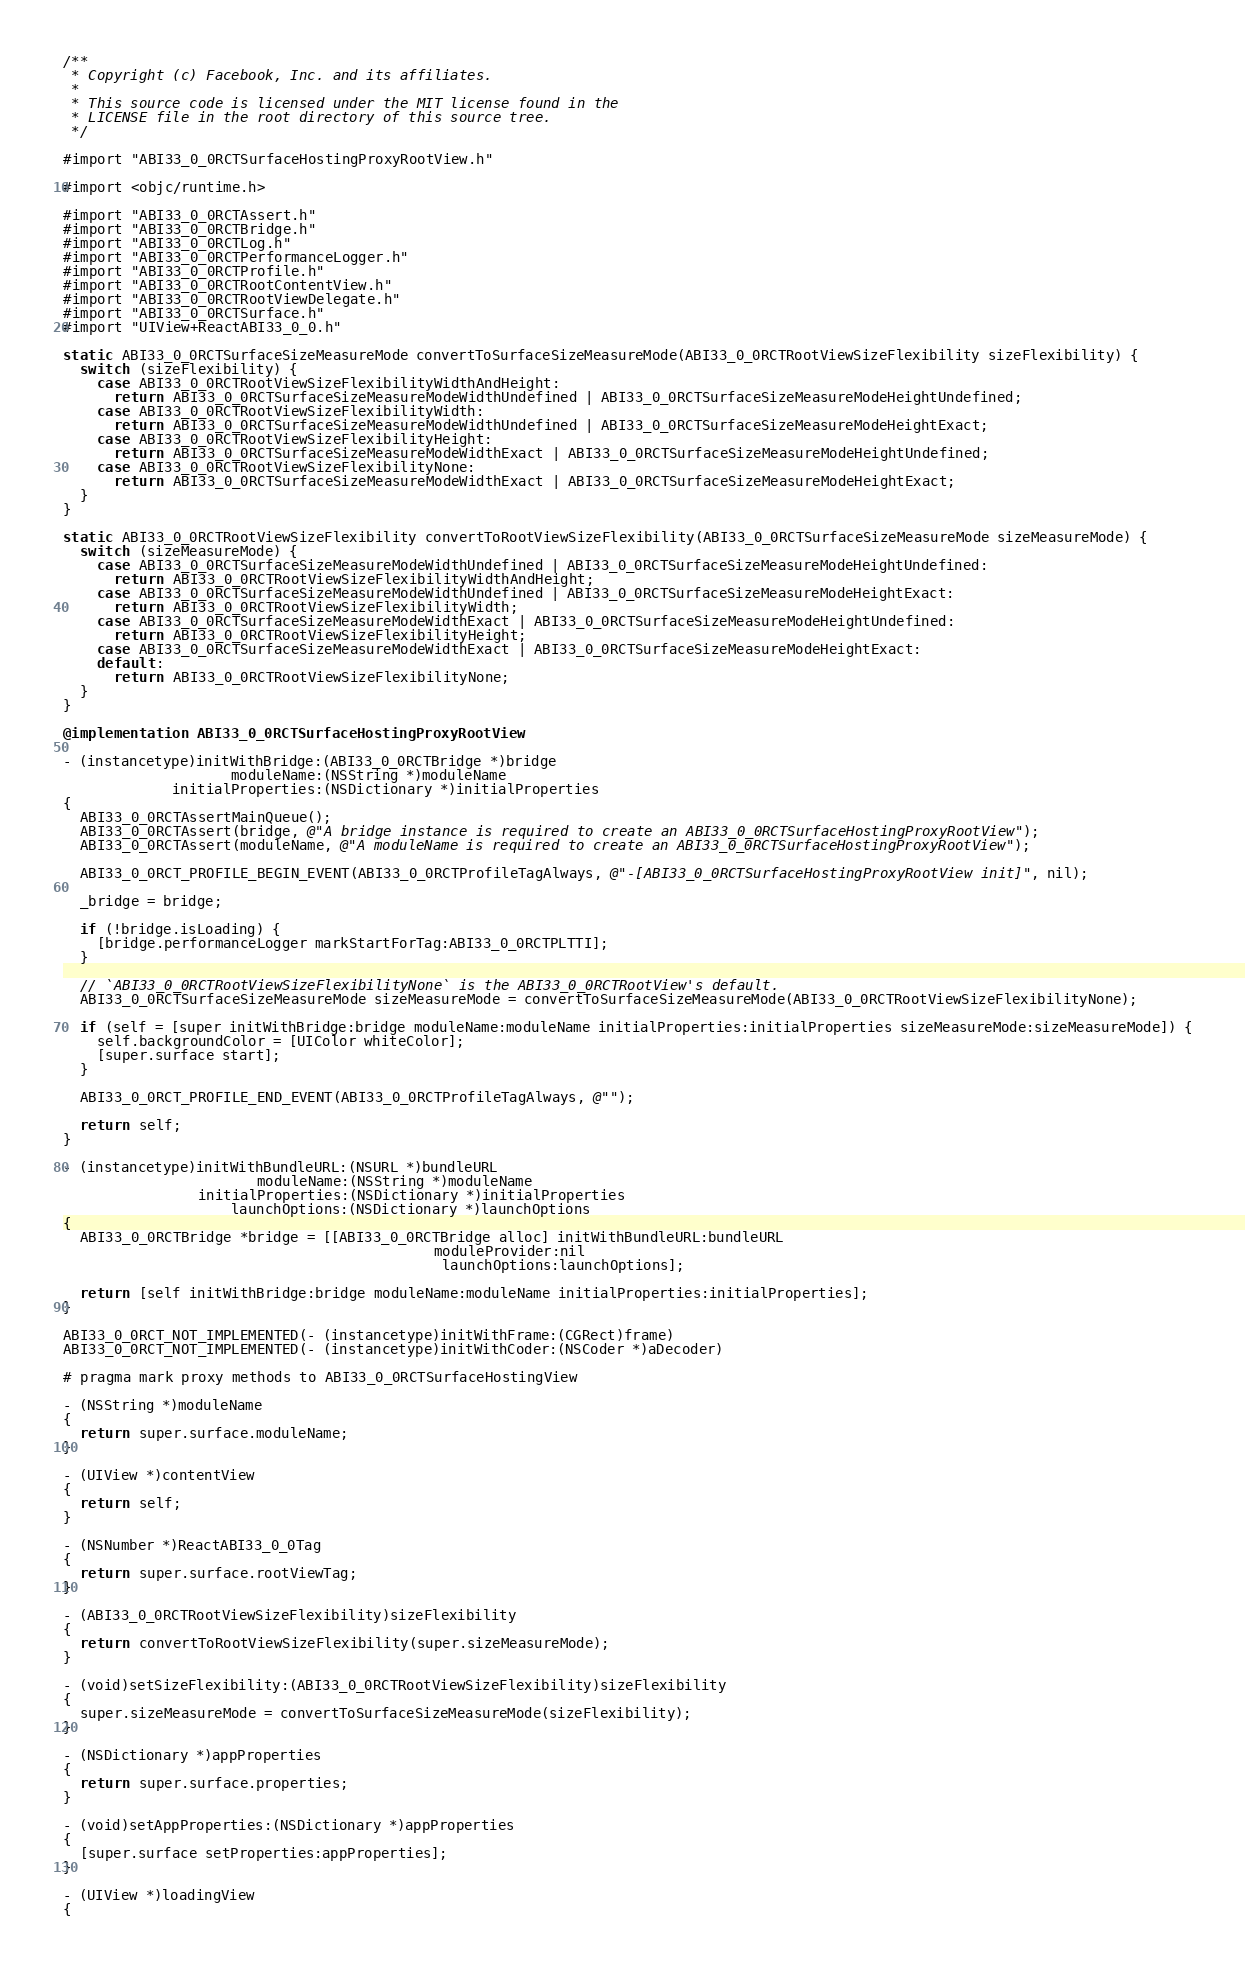Convert code to text. <code><loc_0><loc_0><loc_500><loc_500><_ObjectiveC_>/**
 * Copyright (c) Facebook, Inc. and its affiliates.
 *
 * This source code is licensed under the MIT license found in the
 * LICENSE file in the root directory of this source tree.
 */

#import "ABI33_0_0RCTSurfaceHostingProxyRootView.h"

#import <objc/runtime.h>

#import "ABI33_0_0RCTAssert.h"
#import "ABI33_0_0RCTBridge.h"
#import "ABI33_0_0RCTLog.h"
#import "ABI33_0_0RCTPerformanceLogger.h"
#import "ABI33_0_0RCTProfile.h"
#import "ABI33_0_0RCTRootContentView.h"
#import "ABI33_0_0RCTRootViewDelegate.h"
#import "ABI33_0_0RCTSurface.h"
#import "UIView+ReactABI33_0_0.h"

static ABI33_0_0RCTSurfaceSizeMeasureMode convertToSurfaceSizeMeasureMode(ABI33_0_0RCTRootViewSizeFlexibility sizeFlexibility) {
  switch (sizeFlexibility) {
    case ABI33_0_0RCTRootViewSizeFlexibilityWidthAndHeight:
      return ABI33_0_0RCTSurfaceSizeMeasureModeWidthUndefined | ABI33_0_0RCTSurfaceSizeMeasureModeHeightUndefined;
    case ABI33_0_0RCTRootViewSizeFlexibilityWidth:
      return ABI33_0_0RCTSurfaceSizeMeasureModeWidthUndefined | ABI33_0_0RCTSurfaceSizeMeasureModeHeightExact;
    case ABI33_0_0RCTRootViewSizeFlexibilityHeight:
      return ABI33_0_0RCTSurfaceSizeMeasureModeWidthExact | ABI33_0_0RCTSurfaceSizeMeasureModeHeightUndefined;
    case ABI33_0_0RCTRootViewSizeFlexibilityNone:
      return ABI33_0_0RCTSurfaceSizeMeasureModeWidthExact | ABI33_0_0RCTSurfaceSizeMeasureModeHeightExact;
  }
}

static ABI33_0_0RCTRootViewSizeFlexibility convertToRootViewSizeFlexibility(ABI33_0_0RCTSurfaceSizeMeasureMode sizeMeasureMode) {
  switch (sizeMeasureMode) {
    case ABI33_0_0RCTSurfaceSizeMeasureModeWidthUndefined | ABI33_0_0RCTSurfaceSizeMeasureModeHeightUndefined:
      return ABI33_0_0RCTRootViewSizeFlexibilityWidthAndHeight;
    case ABI33_0_0RCTSurfaceSizeMeasureModeWidthUndefined | ABI33_0_0RCTSurfaceSizeMeasureModeHeightExact:
      return ABI33_0_0RCTRootViewSizeFlexibilityWidth;
    case ABI33_0_0RCTSurfaceSizeMeasureModeWidthExact | ABI33_0_0RCTSurfaceSizeMeasureModeHeightUndefined:
      return ABI33_0_0RCTRootViewSizeFlexibilityHeight;
    case ABI33_0_0RCTSurfaceSizeMeasureModeWidthExact | ABI33_0_0RCTSurfaceSizeMeasureModeHeightExact:
    default:
      return ABI33_0_0RCTRootViewSizeFlexibilityNone;
  }
}

@implementation ABI33_0_0RCTSurfaceHostingProxyRootView

- (instancetype)initWithBridge:(ABI33_0_0RCTBridge *)bridge
                    moduleName:(NSString *)moduleName
             initialProperties:(NSDictionary *)initialProperties
{
  ABI33_0_0RCTAssertMainQueue();
  ABI33_0_0RCTAssert(bridge, @"A bridge instance is required to create an ABI33_0_0RCTSurfaceHostingProxyRootView");
  ABI33_0_0RCTAssert(moduleName, @"A moduleName is required to create an ABI33_0_0RCTSurfaceHostingProxyRootView");

  ABI33_0_0RCT_PROFILE_BEGIN_EVENT(ABI33_0_0RCTProfileTagAlways, @"-[ABI33_0_0RCTSurfaceHostingProxyRootView init]", nil);

  _bridge = bridge;

  if (!bridge.isLoading) {
    [bridge.performanceLogger markStartForTag:ABI33_0_0RCTPLTTI];
  }

  // `ABI33_0_0RCTRootViewSizeFlexibilityNone` is the ABI33_0_0RCTRootView's default.
  ABI33_0_0RCTSurfaceSizeMeasureMode sizeMeasureMode = convertToSurfaceSizeMeasureMode(ABI33_0_0RCTRootViewSizeFlexibilityNone);

  if (self = [super initWithBridge:bridge moduleName:moduleName initialProperties:initialProperties sizeMeasureMode:sizeMeasureMode]) {
    self.backgroundColor = [UIColor whiteColor];
    [super.surface start];
  }

  ABI33_0_0RCT_PROFILE_END_EVENT(ABI33_0_0RCTProfileTagAlways, @"");

  return self;
}

- (instancetype)initWithBundleURL:(NSURL *)bundleURL
                       moduleName:(NSString *)moduleName
                initialProperties:(NSDictionary *)initialProperties
                    launchOptions:(NSDictionary *)launchOptions
{
  ABI33_0_0RCTBridge *bridge = [[ABI33_0_0RCTBridge alloc] initWithBundleURL:bundleURL
                                            moduleProvider:nil
                                             launchOptions:launchOptions];

  return [self initWithBridge:bridge moduleName:moduleName initialProperties:initialProperties];
}

ABI33_0_0RCT_NOT_IMPLEMENTED(- (instancetype)initWithFrame:(CGRect)frame)
ABI33_0_0RCT_NOT_IMPLEMENTED(- (instancetype)initWithCoder:(NSCoder *)aDecoder)

# pragma mark proxy methods to ABI33_0_0RCTSurfaceHostingView

- (NSString *)moduleName
{
  return super.surface.moduleName;
}

- (UIView *)contentView
{
  return self;
}

- (NSNumber *)ReactABI33_0_0Tag
{
  return super.surface.rootViewTag;
}

- (ABI33_0_0RCTRootViewSizeFlexibility)sizeFlexibility
{
  return convertToRootViewSizeFlexibility(super.sizeMeasureMode);
}

- (void)setSizeFlexibility:(ABI33_0_0RCTRootViewSizeFlexibility)sizeFlexibility
{
  super.sizeMeasureMode = convertToSurfaceSizeMeasureMode(sizeFlexibility);
}

- (NSDictionary *)appProperties
{
  return super.surface.properties;
}

- (void)setAppProperties:(NSDictionary *)appProperties
{
  [super.surface setProperties:appProperties];
}

- (UIView *)loadingView
{</code> 